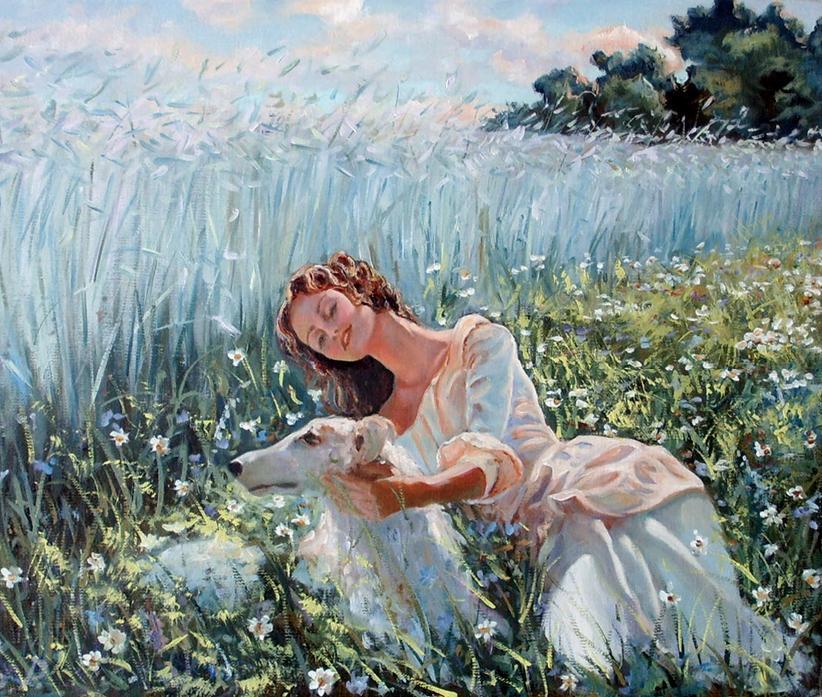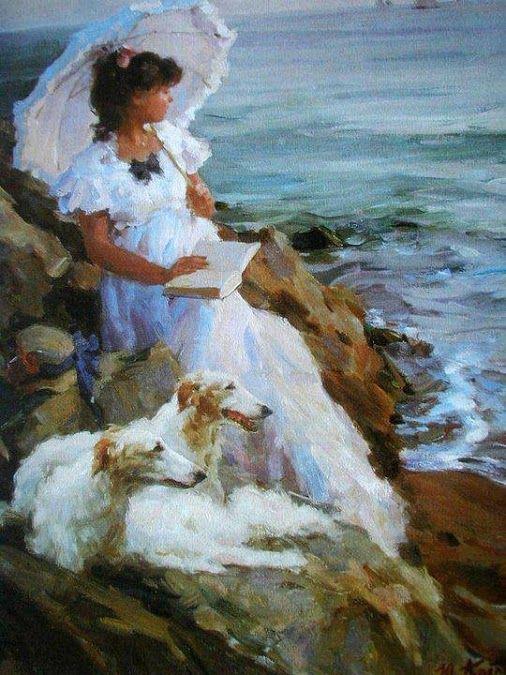The first image is the image on the left, the second image is the image on the right. Assess this claim about the two images: "There is an image with a horse". Correct or not? Answer yes or no. No. 